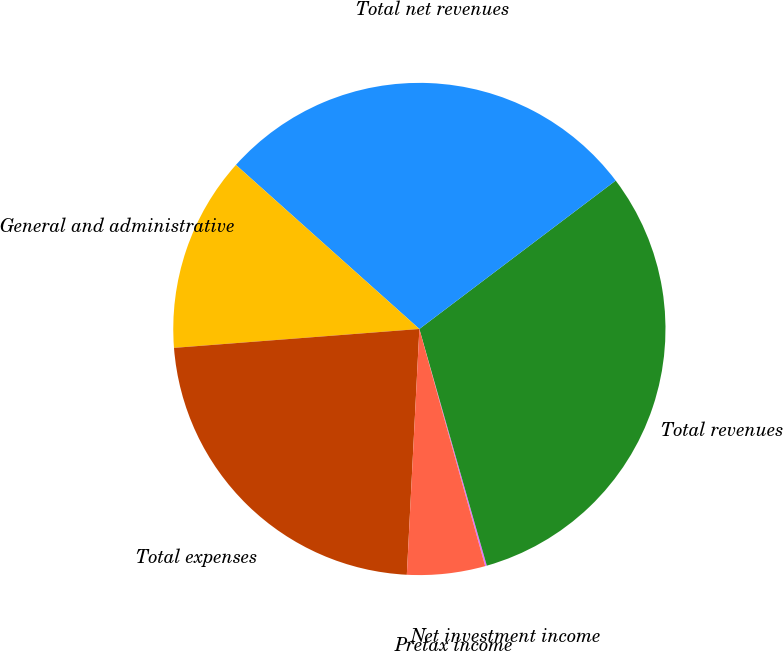Convert chart to OTSL. <chart><loc_0><loc_0><loc_500><loc_500><pie_chart><fcel>Net investment income<fcel>Total revenues<fcel>Total net revenues<fcel>General and administrative<fcel>Total expenses<fcel>Pretax income<nl><fcel>0.11%<fcel>30.89%<fcel>28.09%<fcel>12.84%<fcel>22.97%<fcel>5.12%<nl></chart> 